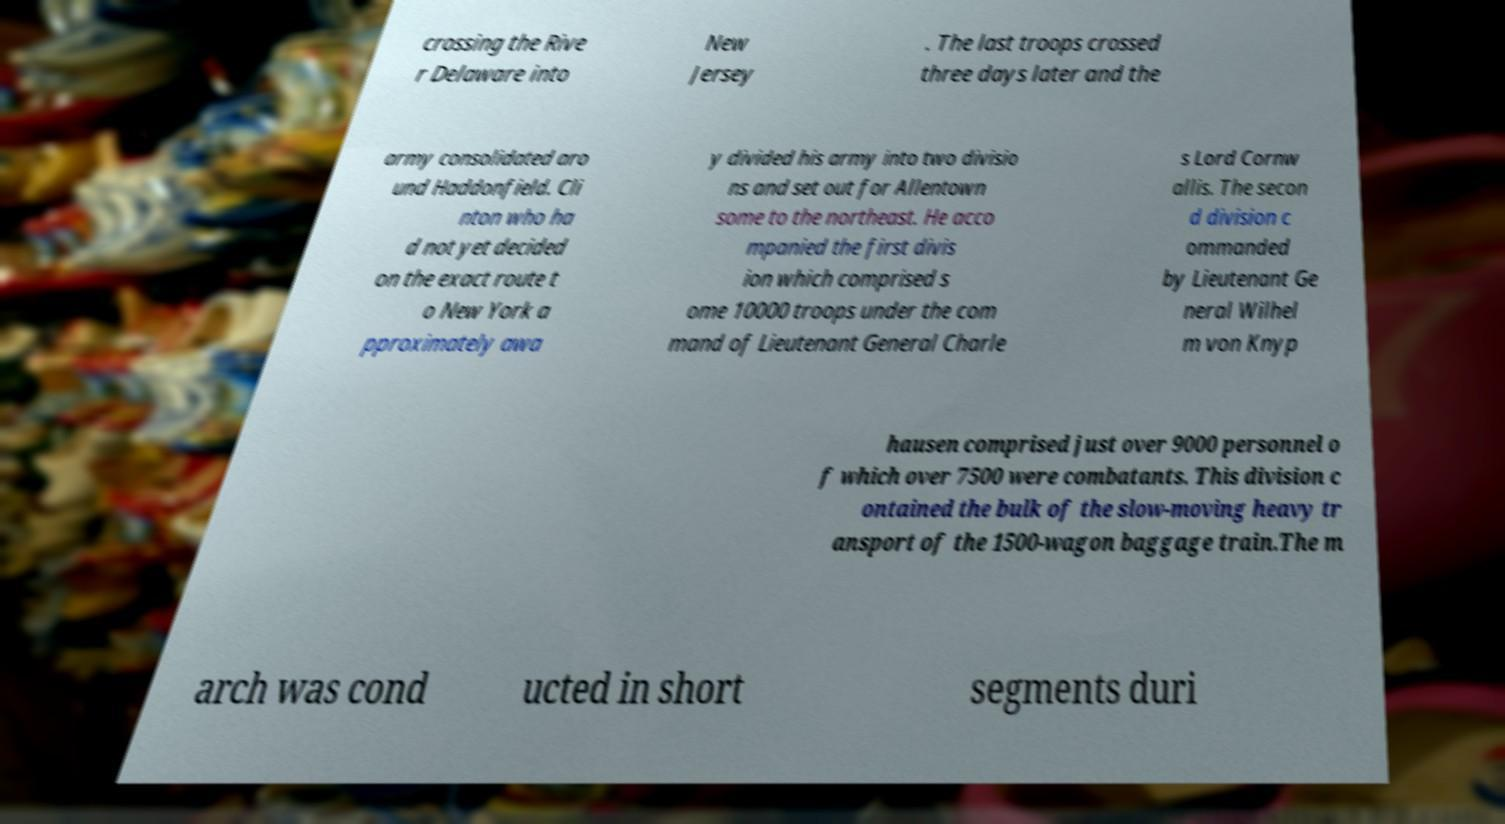Please read and relay the text visible in this image. What does it say? crossing the Rive r Delaware into New Jersey . The last troops crossed three days later and the army consolidated aro und Haddonfield. Cli nton who ha d not yet decided on the exact route t o New York a pproximately awa y divided his army into two divisio ns and set out for Allentown some to the northeast. He acco mpanied the first divis ion which comprised s ome 10000 troops under the com mand of Lieutenant General Charle s Lord Cornw allis. The secon d division c ommanded by Lieutenant Ge neral Wilhel m von Knyp hausen comprised just over 9000 personnel o f which over 7500 were combatants. This division c ontained the bulk of the slow-moving heavy tr ansport of the 1500-wagon baggage train.The m arch was cond ucted in short segments duri 